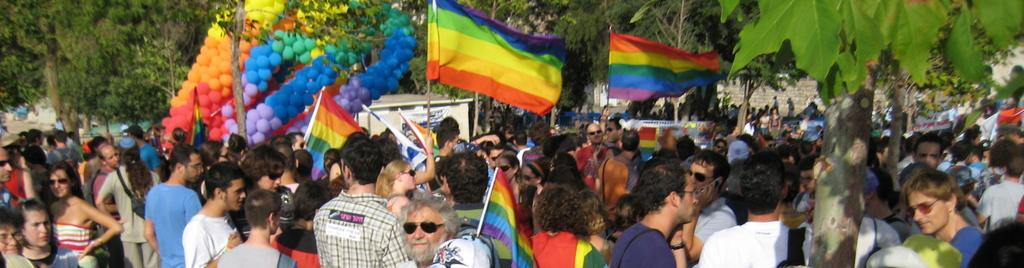What are the people in the image doing? There is a group of people standing in the image, and most of them are holding flags in their hands. What can be seen in the background of the image? There are trees and balloons in the background of the image. What type of orange can be seen in the image? There is no orange present in the image. How does the behavior of the people in the image reflect their mood? The provided facts do not give any information about the people's mood or behavior, so we cannot determine how their behavior reflects their mood. 